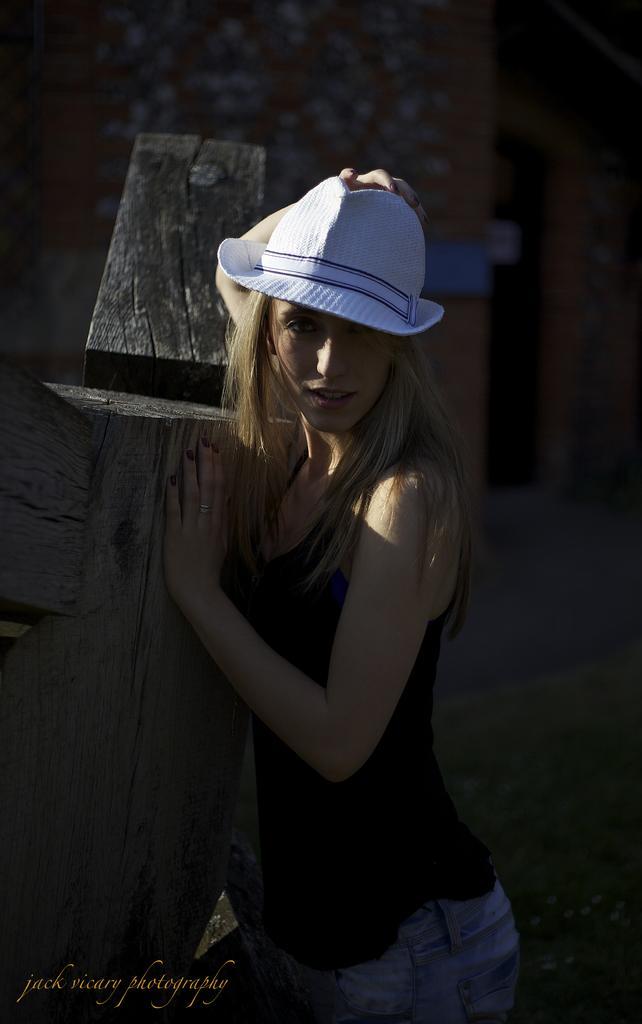Describe this image in one or two sentences. In the image i can see a person wearing a cap and giving a pose for the photo and in the background i can see the dark. 